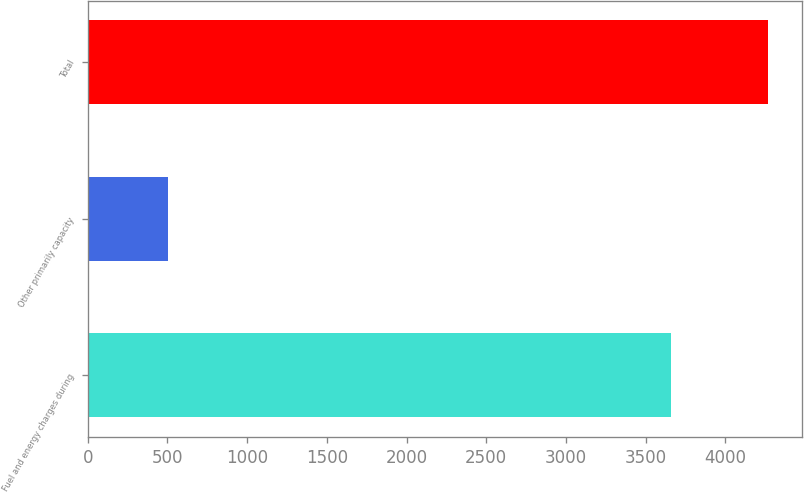Convert chart. <chart><loc_0><loc_0><loc_500><loc_500><bar_chart><fcel>Fuel and energy charges during<fcel>Other primarily capacity<fcel>Total<nl><fcel>3657<fcel>505<fcel>4265<nl></chart> 